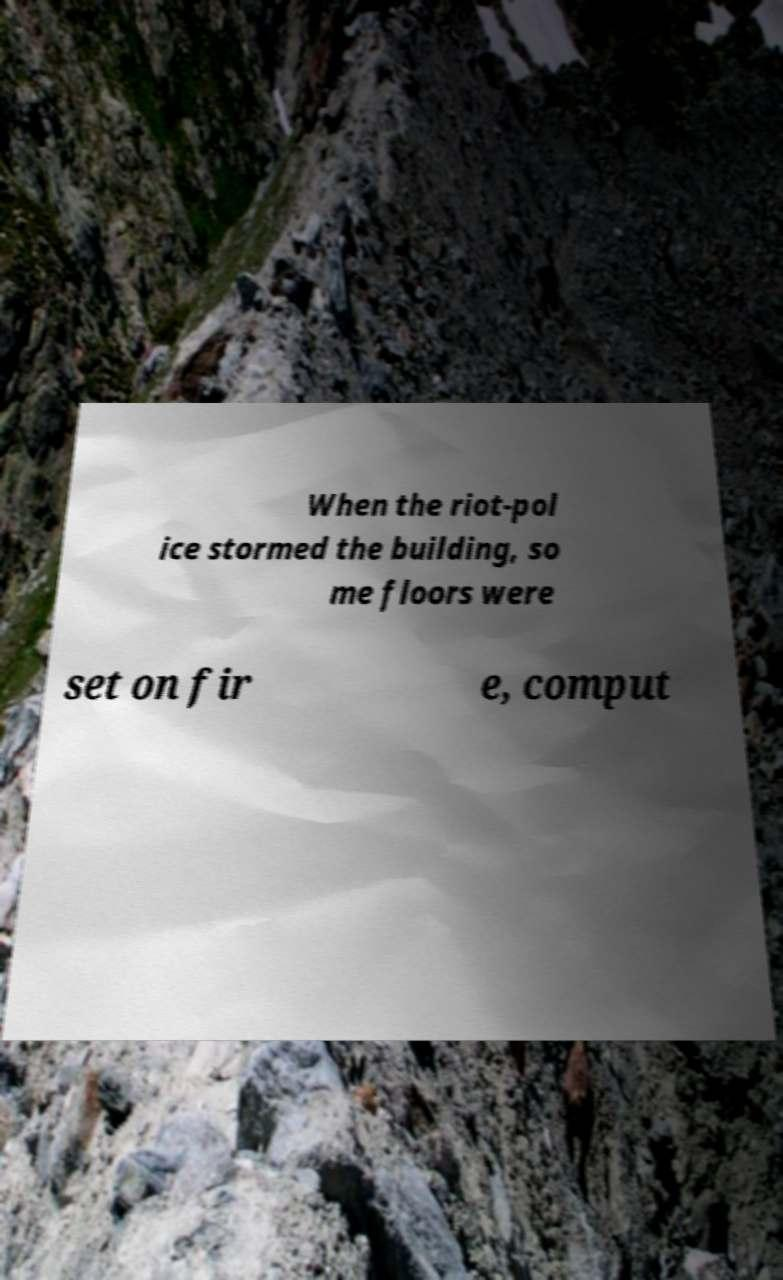I need the written content from this picture converted into text. Can you do that? When the riot-pol ice stormed the building, so me floors were set on fir e, comput 